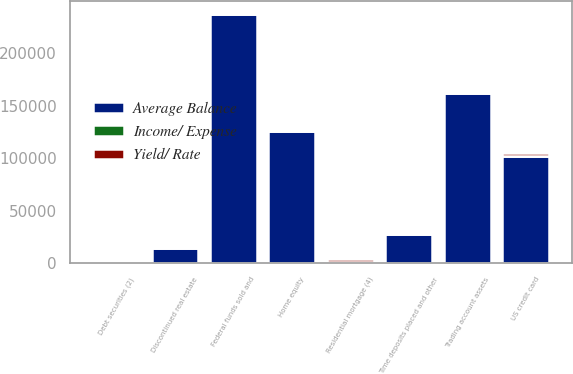Convert chart to OTSL. <chart><loc_0><loc_0><loc_500><loc_500><stacked_bar_chart><ecel><fcel>Time deposits placed and other<fcel>Federal funds sold and<fcel>Trading account assets<fcel>Debt securities (2)<fcel>Residential mortgage (4)<fcel>Home equity<fcel>Discontinued real estate<fcel>US credit card<nl><fcel>Average Balance<fcel>27688<fcel>237453<fcel>161848<fcel>828<fcel>828<fcel>126251<fcel>14073<fcel>102241<nl><fcel>Yield/ Rate<fcel>85<fcel>449<fcel>1354<fcel>2245<fcel>2596<fcel>1207<fcel>128<fcel>2603<nl><fcel>Income/ Expense<fcel>1.19<fcel>0.75<fcel>3.33<fcel>2.69<fcel>3.9<fcel>3.8<fcel>3.65<fcel>10.1<nl></chart> 